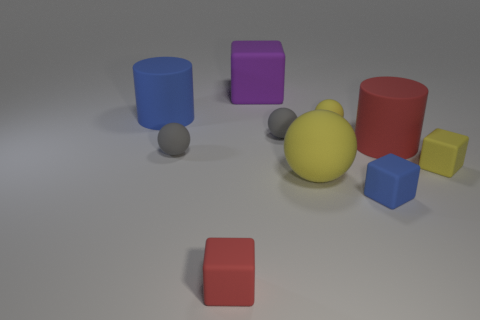Are there any other things that have the same material as the red cube?
Offer a terse response. Yes. Is the shape of the blue matte thing that is behind the big yellow ball the same as the red object that is on the right side of the small blue matte object?
Provide a succinct answer. Yes. Do the block behind the big blue cylinder and the small sphere that is to the left of the large purple rubber thing have the same material?
Your response must be concise. Yes. What shape is the red rubber object that is in front of the blue rubber thing in front of the blue matte cylinder?
Provide a short and direct response. Cube. Is the number of small yellow matte cubes less than the number of small yellow metal cubes?
Ensure brevity in your answer.  No. There is a rubber block that is behind the blue cylinder; what is its color?
Offer a terse response. Purple. The object that is both left of the tiny blue matte cube and in front of the big matte ball is made of what material?
Offer a terse response. Rubber. There is a purple thing that is made of the same material as the small yellow sphere; what shape is it?
Keep it short and to the point. Cube. There is a blue matte object behind the large red object; what number of big purple things are right of it?
Ensure brevity in your answer.  1. How many rubber objects are in front of the large red cylinder and on the right side of the small yellow rubber sphere?
Give a very brief answer. 2. 